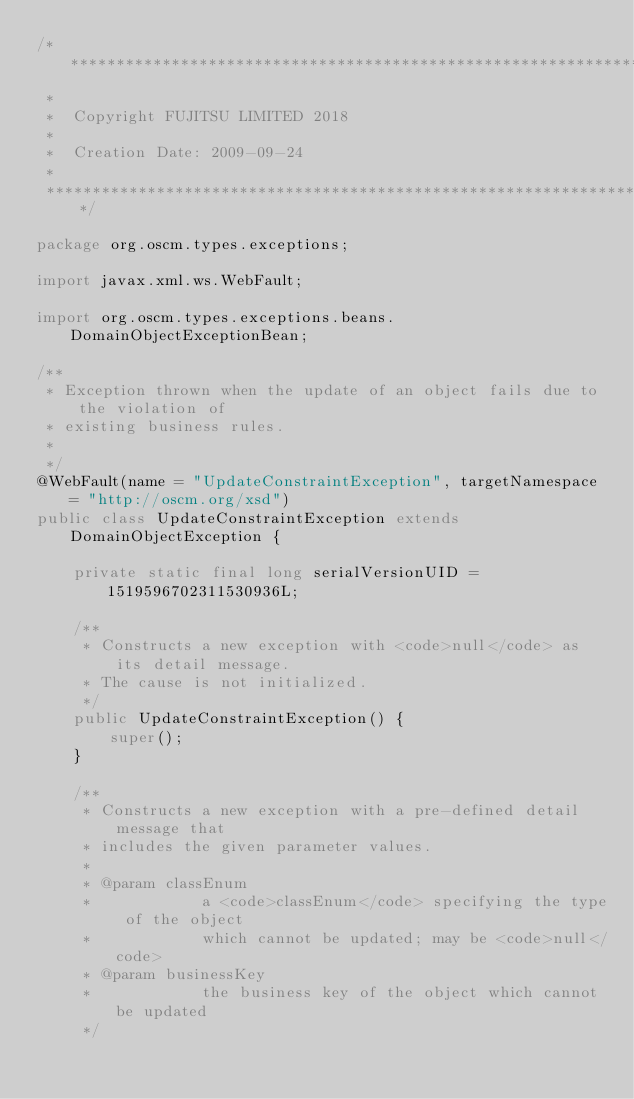Convert code to text. <code><loc_0><loc_0><loc_500><loc_500><_Java_>/*******************************************************************************
 *                                                                              
 *  Copyright FUJITSU LIMITED 2018
 *       
 *  Creation Date: 2009-09-24                                                      
 *                                                                              
 *******************************************************************************/

package org.oscm.types.exceptions;

import javax.xml.ws.WebFault;

import org.oscm.types.exceptions.beans.DomainObjectExceptionBean;

/**
 * Exception thrown when the update of an object fails due to the violation of
 * existing business rules.
 * 
 */
@WebFault(name = "UpdateConstraintException", targetNamespace = "http://oscm.org/xsd")
public class UpdateConstraintException extends DomainObjectException {

    private static final long serialVersionUID = 1519596702311530936L;

    /**
     * Constructs a new exception with <code>null</code> as its detail message.
     * The cause is not initialized.
     */
    public UpdateConstraintException() {
        super();
    }

    /**
     * Constructs a new exception with a pre-defined detail message that
     * includes the given parameter values.
     * 
     * @param classEnum
     *            a <code>classEnum</code> specifying the type of the object
     *            which cannot be updated; may be <code>null</code>
     * @param businessKey
     *            the business key of the object which cannot be updated
     */</code> 